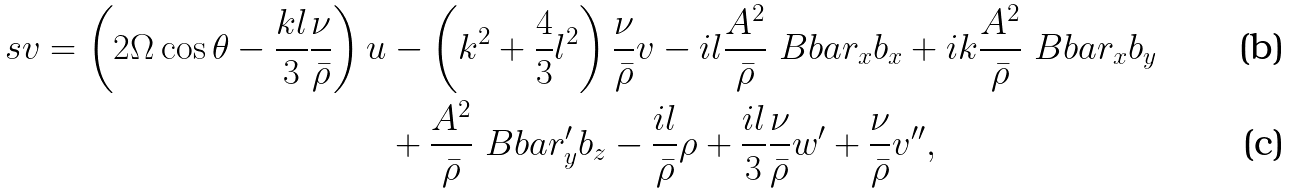Convert formula to latex. <formula><loc_0><loc_0><loc_500><loc_500>s v = \left ( 2 \Omega \cos \theta - \frac { k l } { 3 } \frac { \nu } { \bar { \rho } } \right ) u & - \left ( k ^ { 2 } + \frac { 4 } { 3 } l ^ { 2 } \right ) \frac { \nu } { \bar { \rho } } v - i l \frac { A ^ { 2 } } { \bar { \rho } } \ B b a r _ { x } b _ { x } + i k \frac { A ^ { 2 } } { \bar { \rho } } \ B b a r _ { x } b _ { y } \\ & + \frac { A ^ { 2 } } { \bar { \rho } } \ B b a r _ { y } ^ { \prime } b _ { z } - \frac { i l } { \bar { \rho } } \rho + \frac { i l } { 3 } \frac { \nu } { \bar { \rho } } w ^ { \prime } + \frac { \nu } { \bar { \rho } } v ^ { \prime \prime } ,</formula> 